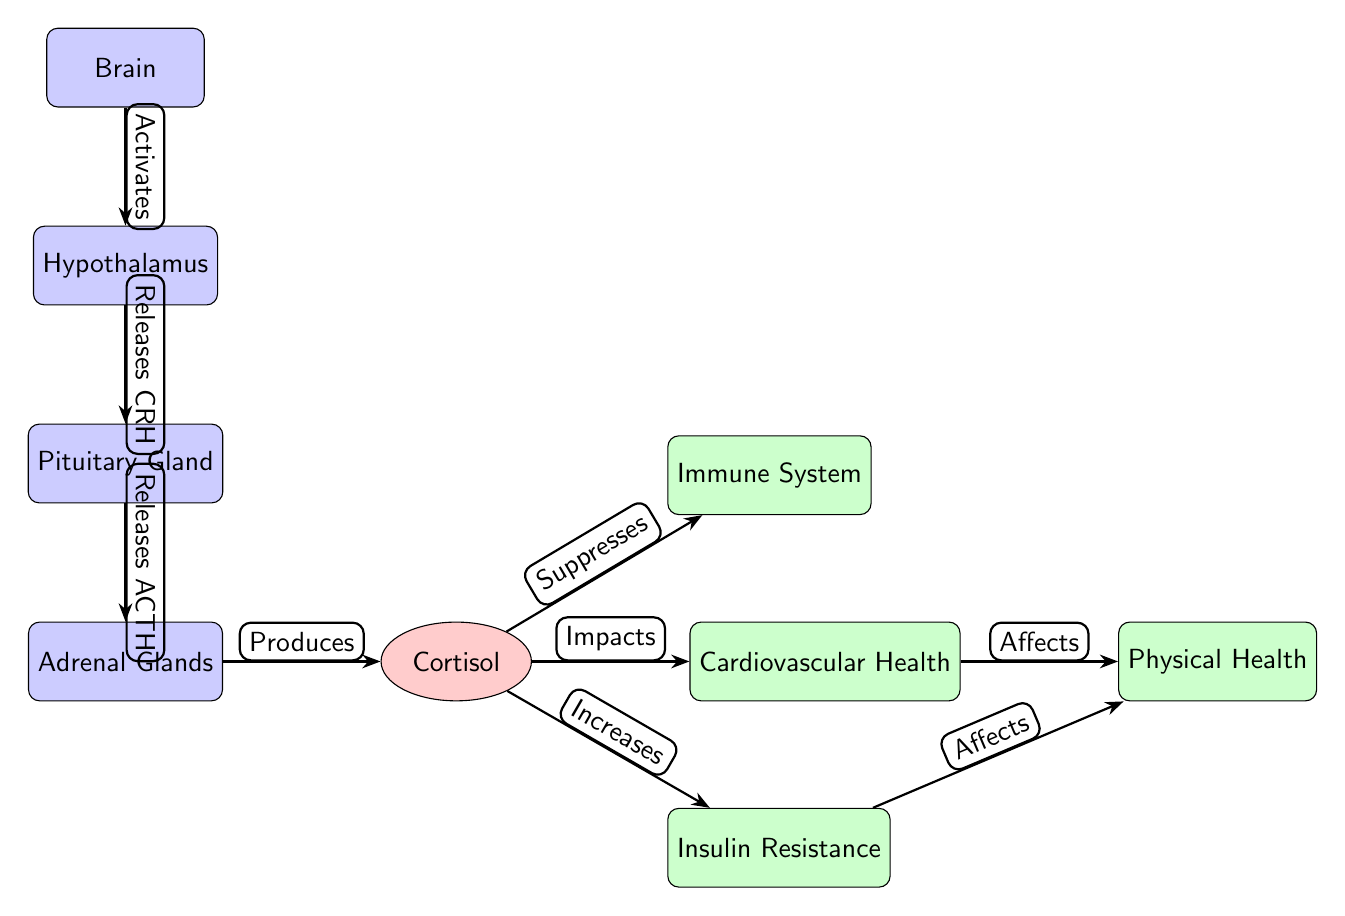What organ activates the hypothalamus? The diagram shows that the Brain activates the Hypothalamus, indicated by the edge labeled "Activates."
Answer: Brain What hormone do the adrenal glands produce? The edge labeled "Produces" from the Adrenal Glands points to the hormone Cortisol, thus Cortisol is the hormone produced.
Answer: Cortisol How many effects are listed in the diagram? The diagram showcases four effects connected to Cortisol. Specifically, these effects are Immune System, Cardiovascular Health, Insulin Resistance, and Physical Health. Hence, the count is four.
Answer: 4 What does cortisol suppress? According to the diagram, Cortisol suppresses the Immune System, as indicated by the edge labeled "Suppresses."
Answer: Immune System Which health aspect is affected by both insulin resistance and cardiovascular health? Both the Insulin Resistance and Cardiovascular Health have an edge leading to Physical Health, showing this is the common health aspect affected by them.
Answer: Physical Health How does the hypothalamus influence the pituitary gland? The relationship is indicated by the edge labeled "Releases CRH," showing that the Hypothalamus releases CRH to influence the Pituitary Gland.
Answer: Releases CRH What is the first step in the brain-body axis stress response? The first step is indicated by the "Activates" edge from the Brain to the Hypothalamus, showing that the Brain initiates the stress response process.
Answer: Activates How does cortisol impact cardiovascular health? The diagram indicates that Cortisol impacts Cardiovascular Health as shown by the edge labeled "Impacts."
Answer: Impacts What is a direct effect of cortisol on insulin levels? The effect of Cortisol on insulin levels is indicated by the edge labeled "Increases," demonstrating its role in promoting Insulin Resistance.
Answer: Increases 